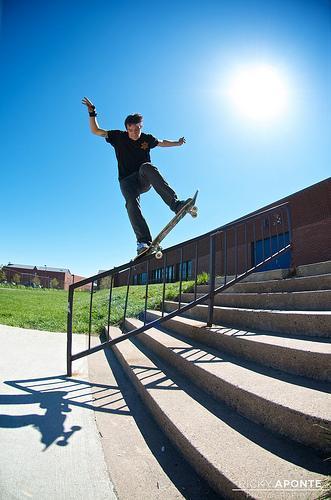How many men are there?
Give a very brief answer. 1. 